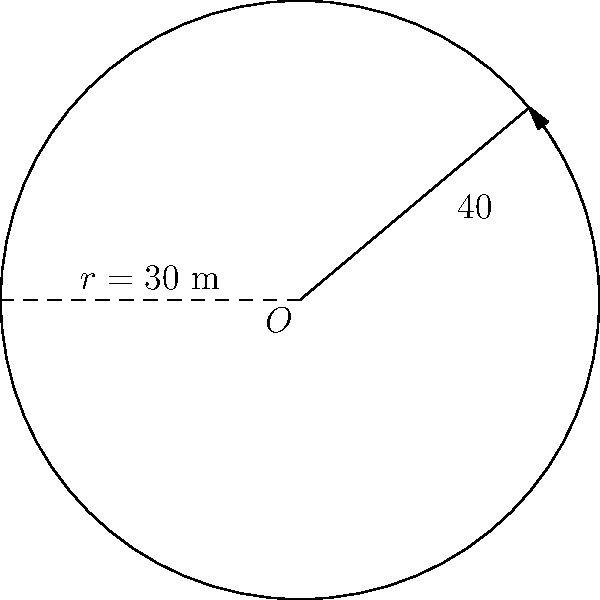A circular dog track has a radius of 30 meters. If a dog's stride length is 1.5 meters and it runs through a central angle of 40°, what distance does the dog cover along the track's circumference? To solve this problem, we'll use the formula for arc length:

$s = r\theta$

Where:
$s$ = arc length (distance covered)
$r$ = radius of the circle
$\theta$ = central angle in radians

Steps:
1) First, we need to convert the central angle from degrees to radians:
   $\theta = 40° \times \frac{\pi}{180°} = \frac{2\pi}{9}$ radians

2) Now we can plug the values into the arc length formula:
   $s = r\theta = 30 \times \frac{2\pi}{9}$

3) Simplify:
   $s = \frac{20\pi}{3}$ meters

4) Calculate the final value:
   $s \approx 20.94$ meters

This distance (20.94 m) should be safe for the dog to run based on its stride length of 1.5 m, as it's equivalent to about 14 strides.
Answer: $\frac{20\pi}{3}$ meters or approximately 20.94 meters 